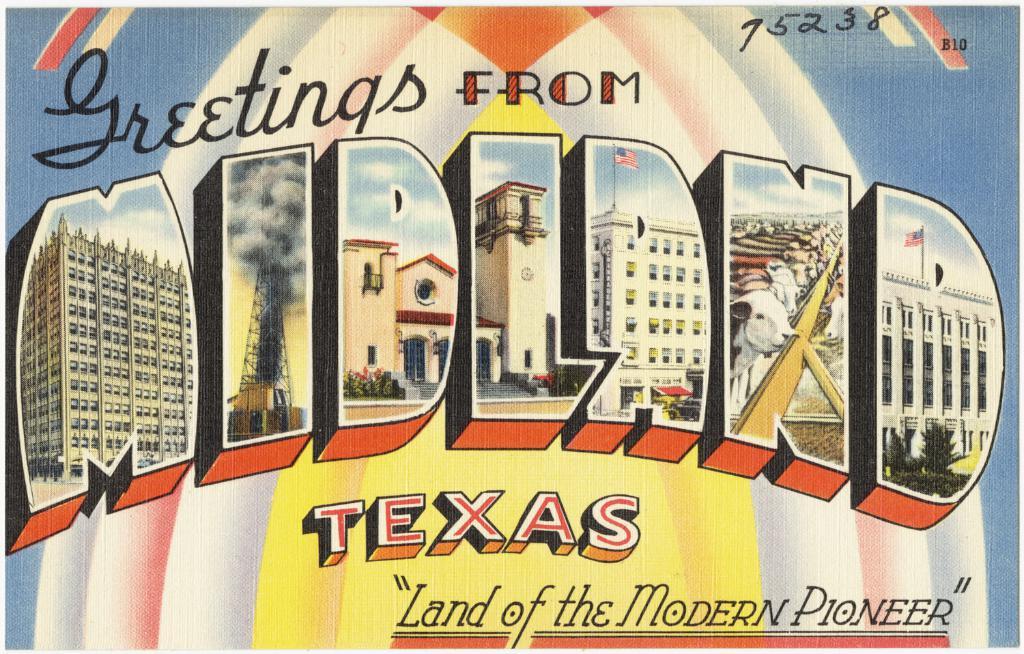Is this an advert?
Ensure brevity in your answer.  Yes. Where is this postcard from?
Your response must be concise. Midland texas. 